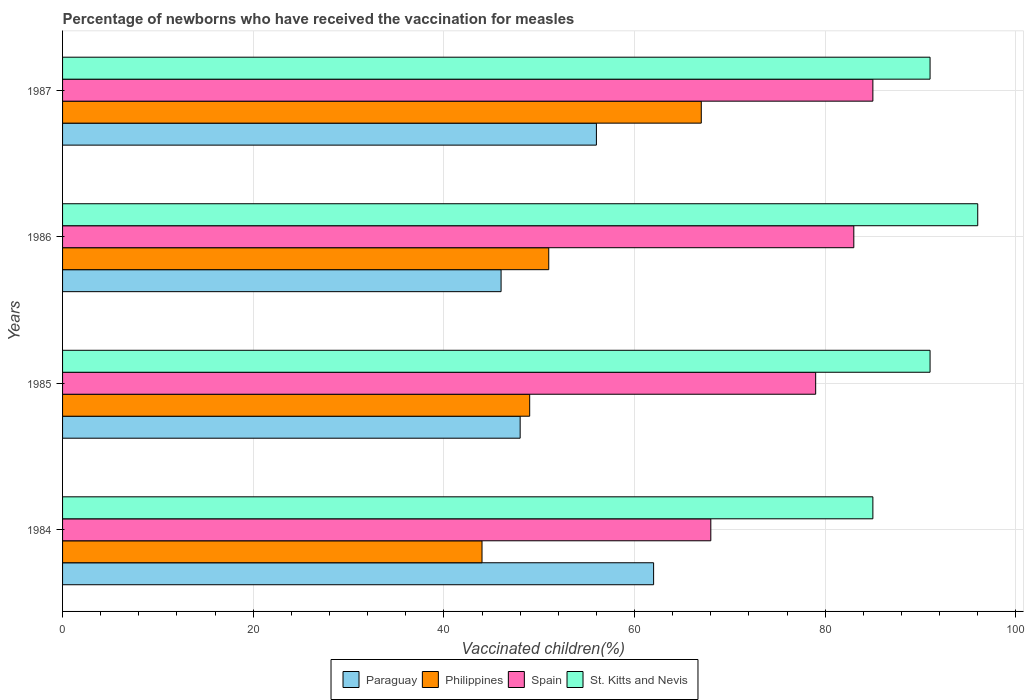How many different coloured bars are there?
Keep it short and to the point. 4. Are the number of bars per tick equal to the number of legend labels?
Provide a succinct answer. Yes. How many bars are there on the 2nd tick from the top?
Keep it short and to the point. 4. How many bars are there on the 4th tick from the bottom?
Offer a terse response. 4. What is the label of the 4th group of bars from the top?
Your response must be concise. 1984. In how many cases, is the number of bars for a given year not equal to the number of legend labels?
Ensure brevity in your answer.  0. Across all years, what is the maximum percentage of vaccinated children in Paraguay?
Give a very brief answer. 62. Across all years, what is the minimum percentage of vaccinated children in Paraguay?
Offer a terse response. 46. In which year was the percentage of vaccinated children in Paraguay minimum?
Offer a terse response. 1986. What is the total percentage of vaccinated children in Spain in the graph?
Ensure brevity in your answer.  315. What is the difference between the percentage of vaccinated children in Paraguay in 1984 and that in 1986?
Provide a short and direct response. 16. What is the difference between the percentage of vaccinated children in St. Kitts and Nevis in 1987 and the percentage of vaccinated children in Paraguay in 1985?
Offer a terse response. 43. What is the average percentage of vaccinated children in St. Kitts and Nevis per year?
Give a very brief answer. 90.75. In how many years, is the percentage of vaccinated children in Paraguay greater than 28 %?
Give a very brief answer. 4. What is the ratio of the percentage of vaccinated children in Spain in 1984 to that in 1986?
Your response must be concise. 0.82. Is the percentage of vaccinated children in St. Kitts and Nevis in 1986 less than that in 1987?
Keep it short and to the point. No. Is the difference between the percentage of vaccinated children in Spain in 1984 and 1985 greater than the difference between the percentage of vaccinated children in Paraguay in 1984 and 1985?
Provide a short and direct response. No. What is the difference between the highest and the second highest percentage of vaccinated children in Philippines?
Your response must be concise. 16. What is the difference between the highest and the lowest percentage of vaccinated children in Paraguay?
Your response must be concise. 16. Is the sum of the percentage of vaccinated children in Paraguay in 1984 and 1987 greater than the maximum percentage of vaccinated children in Philippines across all years?
Your answer should be very brief. Yes. Is it the case that in every year, the sum of the percentage of vaccinated children in Spain and percentage of vaccinated children in Philippines is greater than the sum of percentage of vaccinated children in Paraguay and percentage of vaccinated children in St. Kitts and Nevis?
Your answer should be very brief. Yes. What does the 3rd bar from the top in 1986 represents?
Provide a succinct answer. Philippines. What does the 1st bar from the bottom in 1984 represents?
Make the answer very short. Paraguay. Is it the case that in every year, the sum of the percentage of vaccinated children in Paraguay and percentage of vaccinated children in St. Kitts and Nevis is greater than the percentage of vaccinated children in Philippines?
Offer a terse response. Yes. Are all the bars in the graph horizontal?
Offer a terse response. Yes. How many years are there in the graph?
Make the answer very short. 4. Does the graph contain any zero values?
Keep it short and to the point. No. Does the graph contain grids?
Give a very brief answer. Yes. Where does the legend appear in the graph?
Your response must be concise. Bottom center. How many legend labels are there?
Your response must be concise. 4. What is the title of the graph?
Your answer should be very brief. Percentage of newborns who have received the vaccination for measles. Does "Brunei Darussalam" appear as one of the legend labels in the graph?
Keep it short and to the point. No. What is the label or title of the X-axis?
Your answer should be compact. Vaccinated children(%). What is the label or title of the Y-axis?
Keep it short and to the point. Years. What is the Vaccinated children(%) in Spain in 1984?
Provide a short and direct response. 68. What is the Vaccinated children(%) of St. Kitts and Nevis in 1984?
Provide a short and direct response. 85. What is the Vaccinated children(%) in Spain in 1985?
Provide a short and direct response. 79. What is the Vaccinated children(%) in St. Kitts and Nevis in 1985?
Offer a terse response. 91. What is the Vaccinated children(%) in Paraguay in 1986?
Ensure brevity in your answer.  46. What is the Vaccinated children(%) of Philippines in 1986?
Keep it short and to the point. 51. What is the Vaccinated children(%) in Spain in 1986?
Ensure brevity in your answer.  83. What is the Vaccinated children(%) in St. Kitts and Nevis in 1986?
Ensure brevity in your answer.  96. What is the Vaccinated children(%) of Philippines in 1987?
Ensure brevity in your answer.  67. What is the Vaccinated children(%) in Spain in 1987?
Offer a very short reply. 85. What is the Vaccinated children(%) of St. Kitts and Nevis in 1987?
Your response must be concise. 91. Across all years, what is the maximum Vaccinated children(%) in Spain?
Keep it short and to the point. 85. Across all years, what is the maximum Vaccinated children(%) of St. Kitts and Nevis?
Ensure brevity in your answer.  96. Across all years, what is the minimum Vaccinated children(%) in Philippines?
Keep it short and to the point. 44. Across all years, what is the minimum Vaccinated children(%) of St. Kitts and Nevis?
Ensure brevity in your answer.  85. What is the total Vaccinated children(%) of Paraguay in the graph?
Offer a very short reply. 212. What is the total Vaccinated children(%) of Philippines in the graph?
Offer a very short reply. 211. What is the total Vaccinated children(%) of Spain in the graph?
Offer a very short reply. 315. What is the total Vaccinated children(%) of St. Kitts and Nevis in the graph?
Your response must be concise. 363. What is the difference between the Vaccinated children(%) in Paraguay in 1984 and that in 1985?
Ensure brevity in your answer.  14. What is the difference between the Vaccinated children(%) of Philippines in 1984 and that in 1985?
Provide a succinct answer. -5. What is the difference between the Vaccinated children(%) in St. Kitts and Nevis in 1984 and that in 1985?
Provide a succinct answer. -6. What is the difference between the Vaccinated children(%) of Paraguay in 1984 and that in 1986?
Keep it short and to the point. 16. What is the difference between the Vaccinated children(%) in Spain in 1984 and that in 1986?
Give a very brief answer. -15. What is the difference between the Vaccinated children(%) in St. Kitts and Nevis in 1984 and that in 1986?
Offer a terse response. -11. What is the difference between the Vaccinated children(%) in Paraguay in 1984 and that in 1987?
Offer a terse response. 6. What is the difference between the Vaccinated children(%) in Philippines in 1985 and that in 1986?
Ensure brevity in your answer.  -2. What is the difference between the Vaccinated children(%) in Philippines in 1985 and that in 1987?
Your answer should be compact. -18. What is the difference between the Vaccinated children(%) of Spain in 1985 and that in 1987?
Keep it short and to the point. -6. What is the difference between the Vaccinated children(%) in Philippines in 1986 and that in 1987?
Offer a terse response. -16. What is the difference between the Vaccinated children(%) of St. Kitts and Nevis in 1986 and that in 1987?
Make the answer very short. 5. What is the difference between the Vaccinated children(%) of Paraguay in 1984 and the Vaccinated children(%) of Spain in 1985?
Offer a terse response. -17. What is the difference between the Vaccinated children(%) in Paraguay in 1984 and the Vaccinated children(%) in St. Kitts and Nevis in 1985?
Keep it short and to the point. -29. What is the difference between the Vaccinated children(%) of Philippines in 1984 and the Vaccinated children(%) of Spain in 1985?
Offer a very short reply. -35. What is the difference between the Vaccinated children(%) in Philippines in 1984 and the Vaccinated children(%) in St. Kitts and Nevis in 1985?
Give a very brief answer. -47. What is the difference between the Vaccinated children(%) in Spain in 1984 and the Vaccinated children(%) in St. Kitts and Nevis in 1985?
Offer a very short reply. -23. What is the difference between the Vaccinated children(%) of Paraguay in 1984 and the Vaccinated children(%) of Philippines in 1986?
Give a very brief answer. 11. What is the difference between the Vaccinated children(%) of Paraguay in 1984 and the Vaccinated children(%) of Spain in 1986?
Your answer should be very brief. -21. What is the difference between the Vaccinated children(%) in Paraguay in 1984 and the Vaccinated children(%) in St. Kitts and Nevis in 1986?
Keep it short and to the point. -34. What is the difference between the Vaccinated children(%) in Philippines in 1984 and the Vaccinated children(%) in Spain in 1986?
Your answer should be compact. -39. What is the difference between the Vaccinated children(%) in Philippines in 1984 and the Vaccinated children(%) in St. Kitts and Nevis in 1986?
Offer a terse response. -52. What is the difference between the Vaccinated children(%) in Spain in 1984 and the Vaccinated children(%) in St. Kitts and Nevis in 1986?
Your answer should be compact. -28. What is the difference between the Vaccinated children(%) in Paraguay in 1984 and the Vaccinated children(%) in Philippines in 1987?
Offer a very short reply. -5. What is the difference between the Vaccinated children(%) of Paraguay in 1984 and the Vaccinated children(%) of Spain in 1987?
Offer a terse response. -23. What is the difference between the Vaccinated children(%) of Philippines in 1984 and the Vaccinated children(%) of Spain in 1987?
Give a very brief answer. -41. What is the difference between the Vaccinated children(%) of Philippines in 1984 and the Vaccinated children(%) of St. Kitts and Nevis in 1987?
Make the answer very short. -47. What is the difference between the Vaccinated children(%) in Spain in 1984 and the Vaccinated children(%) in St. Kitts and Nevis in 1987?
Provide a short and direct response. -23. What is the difference between the Vaccinated children(%) in Paraguay in 1985 and the Vaccinated children(%) in Spain in 1986?
Provide a short and direct response. -35. What is the difference between the Vaccinated children(%) of Paraguay in 1985 and the Vaccinated children(%) of St. Kitts and Nevis in 1986?
Offer a terse response. -48. What is the difference between the Vaccinated children(%) in Philippines in 1985 and the Vaccinated children(%) in Spain in 1986?
Keep it short and to the point. -34. What is the difference between the Vaccinated children(%) of Philippines in 1985 and the Vaccinated children(%) of St. Kitts and Nevis in 1986?
Provide a short and direct response. -47. What is the difference between the Vaccinated children(%) of Spain in 1985 and the Vaccinated children(%) of St. Kitts and Nevis in 1986?
Offer a very short reply. -17. What is the difference between the Vaccinated children(%) in Paraguay in 1985 and the Vaccinated children(%) in Philippines in 1987?
Give a very brief answer. -19. What is the difference between the Vaccinated children(%) in Paraguay in 1985 and the Vaccinated children(%) in Spain in 1987?
Offer a very short reply. -37. What is the difference between the Vaccinated children(%) of Paraguay in 1985 and the Vaccinated children(%) of St. Kitts and Nevis in 1987?
Offer a terse response. -43. What is the difference between the Vaccinated children(%) of Philippines in 1985 and the Vaccinated children(%) of Spain in 1987?
Provide a short and direct response. -36. What is the difference between the Vaccinated children(%) of Philippines in 1985 and the Vaccinated children(%) of St. Kitts and Nevis in 1987?
Your response must be concise. -42. What is the difference between the Vaccinated children(%) of Spain in 1985 and the Vaccinated children(%) of St. Kitts and Nevis in 1987?
Make the answer very short. -12. What is the difference between the Vaccinated children(%) in Paraguay in 1986 and the Vaccinated children(%) in Spain in 1987?
Provide a short and direct response. -39. What is the difference between the Vaccinated children(%) in Paraguay in 1986 and the Vaccinated children(%) in St. Kitts and Nevis in 1987?
Your answer should be compact. -45. What is the difference between the Vaccinated children(%) of Philippines in 1986 and the Vaccinated children(%) of Spain in 1987?
Your answer should be compact. -34. What is the difference between the Vaccinated children(%) of Spain in 1986 and the Vaccinated children(%) of St. Kitts and Nevis in 1987?
Offer a terse response. -8. What is the average Vaccinated children(%) of Paraguay per year?
Make the answer very short. 53. What is the average Vaccinated children(%) in Philippines per year?
Provide a short and direct response. 52.75. What is the average Vaccinated children(%) in Spain per year?
Make the answer very short. 78.75. What is the average Vaccinated children(%) in St. Kitts and Nevis per year?
Give a very brief answer. 90.75. In the year 1984, what is the difference between the Vaccinated children(%) of Paraguay and Vaccinated children(%) of Philippines?
Offer a terse response. 18. In the year 1984, what is the difference between the Vaccinated children(%) in Paraguay and Vaccinated children(%) in Spain?
Provide a succinct answer. -6. In the year 1984, what is the difference between the Vaccinated children(%) of Philippines and Vaccinated children(%) of St. Kitts and Nevis?
Ensure brevity in your answer.  -41. In the year 1985, what is the difference between the Vaccinated children(%) in Paraguay and Vaccinated children(%) in Spain?
Ensure brevity in your answer.  -31. In the year 1985, what is the difference between the Vaccinated children(%) of Paraguay and Vaccinated children(%) of St. Kitts and Nevis?
Ensure brevity in your answer.  -43. In the year 1985, what is the difference between the Vaccinated children(%) in Philippines and Vaccinated children(%) in St. Kitts and Nevis?
Provide a succinct answer. -42. In the year 1986, what is the difference between the Vaccinated children(%) in Paraguay and Vaccinated children(%) in Philippines?
Offer a terse response. -5. In the year 1986, what is the difference between the Vaccinated children(%) in Paraguay and Vaccinated children(%) in Spain?
Offer a very short reply. -37. In the year 1986, what is the difference between the Vaccinated children(%) of Philippines and Vaccinated children(%) of Spain?
Provide a succinct answer. -32. In the year 1986, what is the difference between the Vaccinated children(%) in Philippines and Vaccinated children(%) in St. Kitts and Nevis?
Make the answer very short. -45. In the year 1986, what is the difference between the Vaccinated children(%) in Spain and Vaccinated children(%) in St. Kitts and Nevis?
Ensure brevity in your answer.  -13. In the year 1987, what is the difference between the Vaccinated children(%) of Paraguay and Vaccinated children(%) of Philippines?
Your answer should be very brief. -11. In the year 1987, what is the difference between the Vaccinated children(%) in Paraguay and Vaccinated children(%) in St. Kitts and Nevis?
Provide a short and direct response. -35. In the year 1987, what is the difference between the Vaccinated children(%) in Spain and Vaccinated children(%) in St. Kitts and Nevis?
Your answer should be compact. -6. What is the ratio of the Vaccinated children(%) of Paraguay in 1984 to that in 1985?
Provide a succinct answer. 1.29. What is the ratio of the Vaccinated children(%) of Philippines in 1984 to that in 1985?
Provide a succinct answer. 0.9. What is the ratio of the Vaccinated children(%) of Spain in 1984 to that in 1985?
Give a very brief answer. 0.86. What is the ratio of the Vaccinated children(%) in St. Kitts and Nevis in 1984 to that in 1985?
Your answer should be compact. 0.93. What is the ratio of the Vaccinated children(%) of Paraguay in 1984 to that in 1986?
Provide a succinct answer. 1.35. What is the ratio of the Vaccinated children(%) in Philippines in 1984 to that in 1986?
Give a very brief answer. 0.86. What is the ratio of the Vaccinated children(%) in Spain in 1984 to that in 1986?
Your answer should be very brief. 0.82. What is the ratio of the Vaccinated children(%) in St. Kitts and Nevis in 1984 to that in 1986?
Keep it short and to the point. 0.89. What is the ratio of the Vaccinated children(%) in Paraguay in 1984 to that in 1987?
Ensure brevity in your answer.  1.11. What is the ratio of the Vaccinated children(%) of Philippines in 1984 to that in 1987?
Your answer should be compact. 0.66. What is the ratio of the Vaccinated children(%) in Spain in 1984 to that in 1987?
Give a very brief answer. 0.8. What is the ratio of the Vaccinated children(%) in St. Kitts and Nevis in 1984 to that in 1987?
Give a very brief answer. 0.93. What is the ratio of the Vaccinated children(%) of Paraguay in 1985 to that in 1986?
Ensure brevity in your answer.  1.04. What is the ratio of the Vaccinated children(%) of Philippines in 1985 to that in 1986?
Make the answer very short. 0.96. What is the ratio of the Vaccinated children(%) in Spain in 1985 to that in 1986?
Provide a succinct answer. 0.95. What is the ratio of the Vaccinated children(%) in St. Kitts and Nevis in 1985 to that in 1986?
Ensure brevity in your answer.  0.95. What is the ratio of the Vaccinated children(%) of Philippines in 1985 to that in 1987?
Your answer should be compact. 0.73. What is the ratio of the Vaccinated children(%) of Spain in 1985 to that in 1987?
Offer a very short reply. 0.93. What is the ratio of the Vaccinated children(%) of Paraguay in 1986 to that in 1987?
Your answer should be very brief. 0.82. What is the ratio of the Vaccinated children(%) in Philippines in 1986 to that in 1987?
Offer a very short reply. 0.76. What is the ratio of the Vaccinated children(%) of Spain in 1986 to that in 1987?
Provide a short and direct response. 0.98. What is the ratio of the Vaccinated children(%) in St. Kitts and Nevis in 1986 to that in 1987?
Provide a succinct answer. 1.05. What is the difference between the highest and the second highest Vaccinated children(%) in Spain?
Ensure brevity in your answer.  2. What is the difference between the highest and the lowest Vaccinated children(%) of Philippines?
Keep it short and to the point. 23. What is the difference between the highest and the lowest Vaccinated children(%) in Spain?
Give a very brief answer. 17. What is the difference between the highest and the lowest Vaccinated children(%) in St. Kitts and Nevis?
Make the answer very short. 11. 